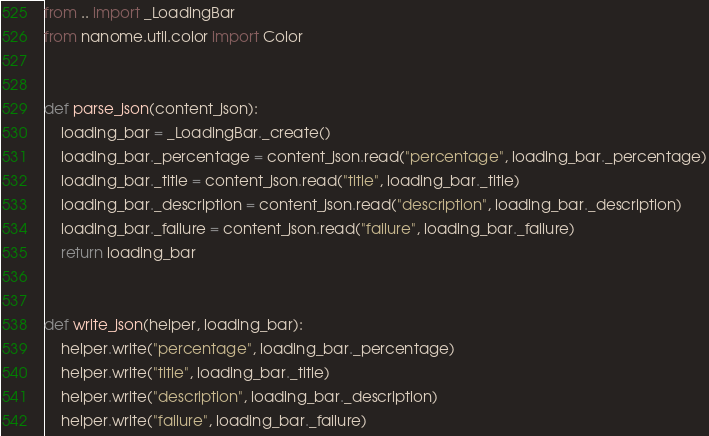Convert code to text. <code><loc_0><loc_0><loc_500><loc_500><_Python_>from .. import _LoadingBar
from nanome.util.color import Color


def parse_json(content_json):
    loading_bar = _LoadingBar._create()
    loading_bar._percentage = content_json.read("percentage", loading_bar._percentage)
    loading_bar._title = content_json.read("title", loading_bar._title)
    loading_bar._description = content_json.read("description", loading_bar._description)
    loading_bar._failure = content_json.read("failure", loading_bar._failure)
    return loading_bar


def write_json(helper, loading_bar):
    helper.write("percentage", loading_bar._percentage)
    helper.write("title", loading_bar._title)
    helper.write("description", loading_bar._description)
    helper.write("failure", loading_bar._failure)
</code> 